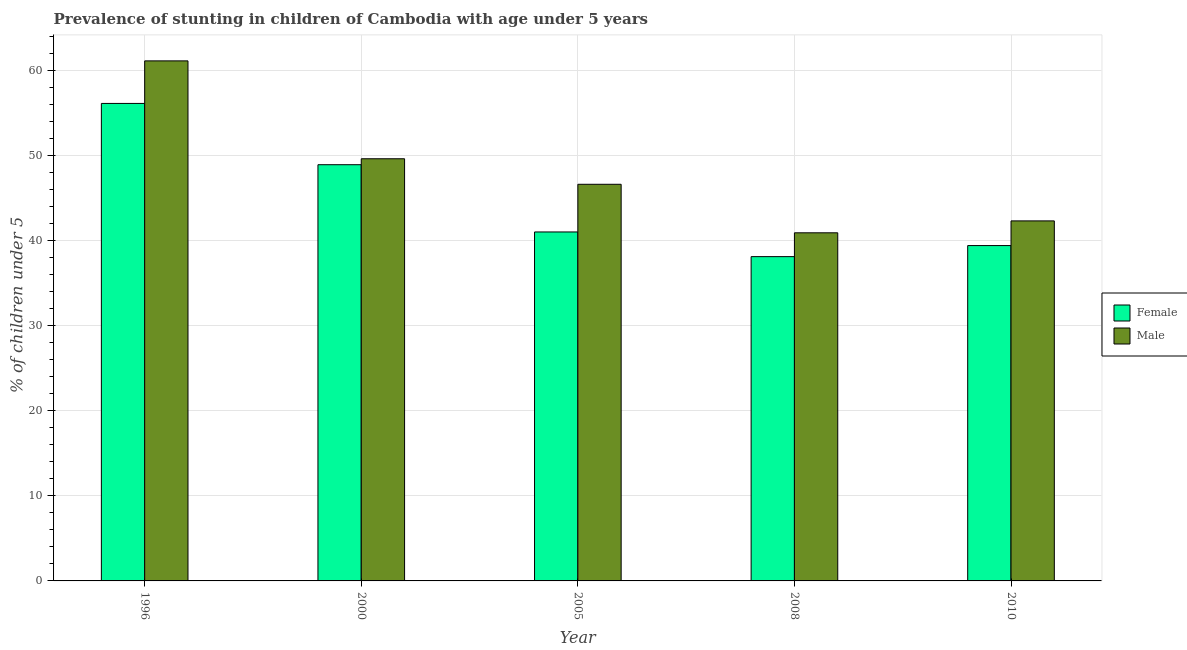Are the number of bars per tick equal to the number of legend labels?
Your answer should be very brief. Yes. Are the number of bars on each tick of the X-axis equal?
Provide a succinct answer. Yes. What is the percentage of stunted male children in 2010?
Make the answer very short. 42.3. Across all years, what is the maximum percentage of stunted female children?
Your response must be concise. 56.1. Across all years, what is the minimum percentage of stunted female children?
Your answer should be compact. 38.1. In which year was the percentage of stunted female children minimum?
Provide a succinct answer. 2008. What is the total percentage of stunted male children in the graph?
Provide a short and direct response. 240.5. What is the difference between the percentage of stunted female children in 2000 and that in 2010?
Offer a terse response. 9.5. What is the difference between the percentage of stunted male children in 2008 and the percentage of stunted female children in 2000?
Make the answer very short. -8.7. What is the average percentage of stunted female children per year?
Give a very brief answer. 44.7. What is the ratio of the percentage of stunted male children in 2005 to that in 2010?
Ensure brevity in your answer.  1.1. What is the difference between the highest and the lowest percentage of stunted male children?
Give a very brief answer. 20.2. In how many years, is the percentage of stunted female children greater than the average percentage of stunted female children taken over all years?
Ensure brevity in your answer.  2. Is the sum of the percentage of stunted male children in 1996 and 2010 greater than the maximum percentage of stunted female children across all years?
Keep it short and to the point. Yes. What does the 1st bar from the left in 1996 represents?
Provide a short and direct response. Female. Does the graph contain any zero values?
Keep it short and to the point. No. Does the graph contain grids?
Provide a succinct answer. Yes. How many legend labels are there?
Provide a short and direct response. 2. What is the title of the graph?
Provide a succinct answer. Prevalence of stunting in children of Cambodia with age under 5 years. Does "Current US$" appear as one of the legend labels in the graph?
Keep it short and to the point. No. What is the label or title of the X-axis?
Provide a succinct answer. Year. What is the label or title of the Y-axis?
Make the answer very short.  % of children under 5. What is the  % of children under 5 in Female in 1996?
Your answer should be compact. 56.1. What is the  % of children under 5 of Male in 1996?
Give a very brief answer. 61.1. What is the  % of children under 5 in Female in 2000?
Your answer should be compact. 48.9. What is the  % of children under 5 in Male in 2000?
Provide a short and direct response. 49.6. What is the  % of children under 5 in Male in 2005?
Make the answer very short. 46.6. What is the  % of children under 5 of Female in 2008?
Ensure brevity in your answer.  38.1. What is the  % of children under 5 of Male in 2008?
Give a very brief answer. 40.9. What is the  % of children under 5 of Female in 2010?
Provide a succinct answer. 39.4. What is the  % of children under 5 in Male in 2010?
Provide a short and direct response. 42.3. Across all years, what is the maximum  % of children under 5 of Female?
Keep it short and to the point. 56.1. Across all years, what is the maximum  % of children under 5 in Male?
Your answer should be very brief. 61.1. Across all years, what is the minimum  % of children under 5 of Female?
Give a very brief answer. 38.1. Across all years, what is the minimum  % of children under 5 in Male?
Provide a succinct answer. 40.9. What is the total  % of children under 5 in Female in the graph?
Your answer should be very brief. 223.5. What is the total  % of children under 5 of Male in the graph?
Offer a terse response. 240.5. What is the difference between the  % of children under 5 of Male in 1996 and that in 2000?
Provide a short and direct response. 11.5. What is the difference between the  % of children under 5 in Male in 1996 and that in 2005?
Your answer should be very brief. 14.5. What is the difference between the  % of children under 5 of Male in 1996 and that in 2008?
Make the answer very short. 20.2. What is the difference between the  % of children under 5 of Male in 1996 and that in 2010?
Your answer should be very brief. 18.8. What is the difference between the  % of children under 5 in Female in 2000 and that in 2008?
Your answer should be very brief. 10.8. What is the difference between the  % of children under 5 in Male in 2000 and that in 2008?
Provide a short and direct response. 8.7. What is the difference between the  % of children under 5 in Male in 2000 and that in 2010?
Your answer should be very brief. 7.3. What is the difference between the  % of children under 5 in Female in 2005 and that in 2008?
Your answer should be very brief. 2.9. What is the difference between the  % of children under 5 of Male in 2005 and that in 2008?
Your response must be concise. 5.7. What is the difference between the  % of children under 5 of Female in 2008 and that in 2010?
Keep it short and to the point. -1.3. What is the difference between the  % of children under 5 of Female in 1996 and the  % of children under 5 of Male in 2005?
Make the answer very short. 9.5. What is the difference between the  % of children under 5 of Female in 2000 and the  % of children under 5 of Male in 2005?
Provide a short and direct response. 2.3. What is the difference between the  % of children under 5 in Female in 2000 and the  % of children under 5 in Male in 2008?
Make the answer very short. 8. What is the average  % of children under 5 of Female per year?
Your answer should be compact. 44.7. What is the average  % of children under 5 in Male per year?
Provide a succinct answer. 48.1. In the year 2005, what is the difference between the  % of children under 5 in Female and  % of children under 5 in Male?
Make the answer very short. -5.6. In the year 2008, what is the difference between the  % of children under 5 of Female and  % of children under 5 of Male?
Your answer should be very brief. -2.8. What is the ratio of the  % of children under 5 in Female in 1996 to that in 2000?
Give a very brief answer. 1.15. What is the ratio of the  % of children under 5 of Male in 1996 to that in 2000?
Give a very brief answer. 1.23. What is the ratio of the  % of children under 5 of Female in 1996 to that in 2005?
Keep it short and to the point. 1.37. What is the ratio of the  % of children under 5 in Male in 1996 to that in 2005?
Ensure brevity in your answer.  1.31. What is the ratio of the  % of children under 5 in Female in 1996 to that in 2008?
Provide a short and direct response. 1.47. What is the ratio of the  % of children under 5 in Male in 1996 to that in 2008?
Keep it short and to the point. 1.49. What is the ratio of the  % of children under 5 in Female in 1996 to that in 2010?
Make the answer very short. 1.42. What is the ratio of the  % of children under 5 of Male in 1996 to that in 2010?
Your answer should be compact. 1.44. What is the ratio of the  % of children under 5 in Female in 2000 to that in 2005?
Your response must be concise. 1.19. What is the ratio of the  % of children under 5 in Male in 2000 to that in 2005?
Offer a very short reply. 1.06. What is the ratio of the  % of children under 5 in Female in 2000 to that in 2008?
Provide a succinct answer. 1.28. What is the ratio of the  % of children under 5 in Male in 2000 to that in 2008?
Give a very brief answer. 1.21. What is the ratio of the  % of children under 5 of Female in 2000 to that in 2010?
Provide a short and direct response. 1.24. What is the ratio of the  % of children under 5 of Male in 2000 to that in 2010?
Offer a very short reply. 1.17. What is the ratio of the  % of children under 5 in Female in 2005 to that in 2008?
Your response must be concise. 1.08. What is the ratio of the  % of children under 5 of Male in 2005 to that in 2008?
Your answer should be very brief. 1.14. What is the ratio of the  % of children under 5 of Female in 2005 to that in 2010?
Your answer should be very brief. 1.04. What is the ratio of the  % of children under 5 in Male in 2005 to that in 2010?
Offer a very short reply. 1.1. What is the ratio of the  % of children under 5 of Male in 2008 to that in 2010?
Keep it short and to the point. 0.97. What is the difference between the highest and the second highest  % of children under 5 in Male?
Ensure brevity in your answer.  11.5. What is the difference between the highest and the lowest  % of children under 5 of Female?
Give a very brief answer. 18. What is the difference between the highest and the lowest  % of children under 5 in Male?
Your answer should be very brief. 20.2. 